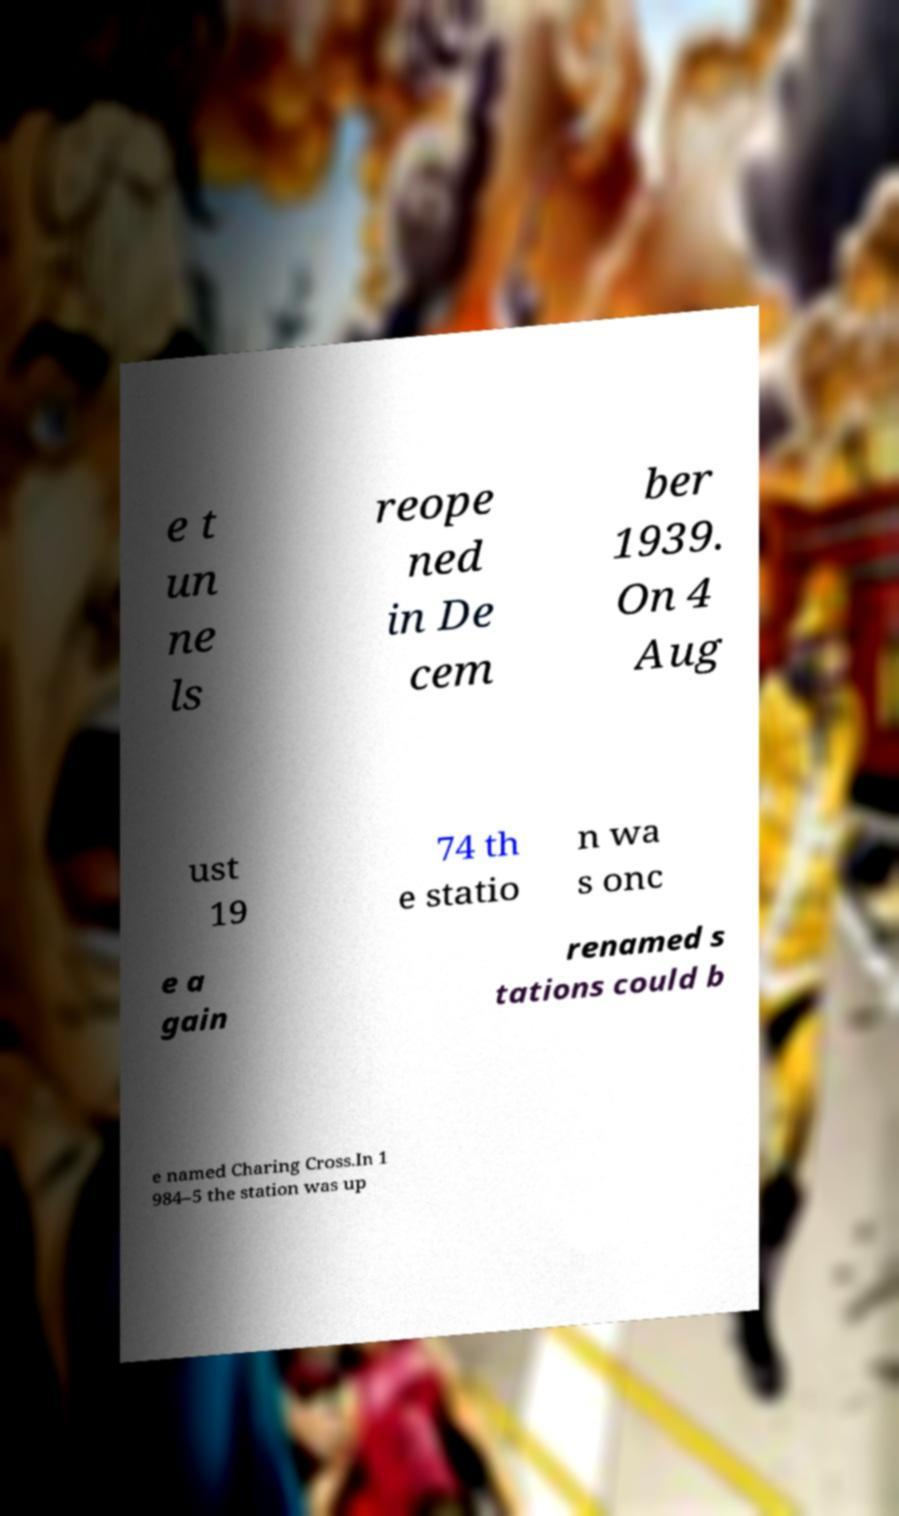There's text embedded in this image that I need extracted. Can you transcribe it verbatim? e t un ne ls reope ned in De cem ber 1939. On 4 Aug ust 19 74 th e statio n wa s onc e a gain renamed s tations could b e named Charing Cross.In 1 984–5 the station was up 